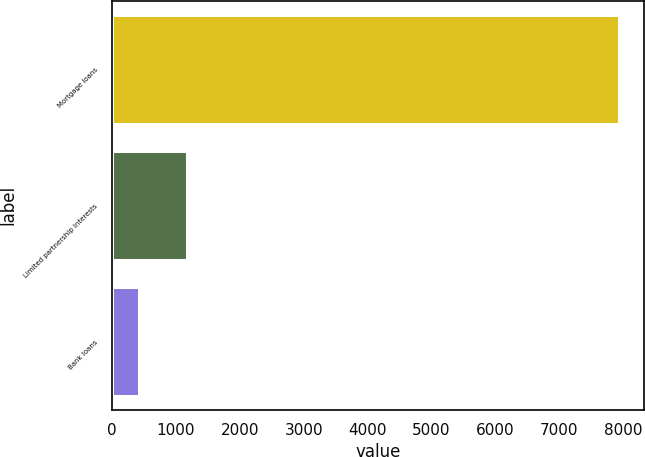Convert chart to OTSL. <chart><loc_0><loc_0><loc_500><loc_500><bar_chart><fcel>Mortgage loans<fcel>Limited partnership interests<fcel>Bank loans<nl><fcel>7935<fcel>1171.5<fcel>420<nl></chart> 